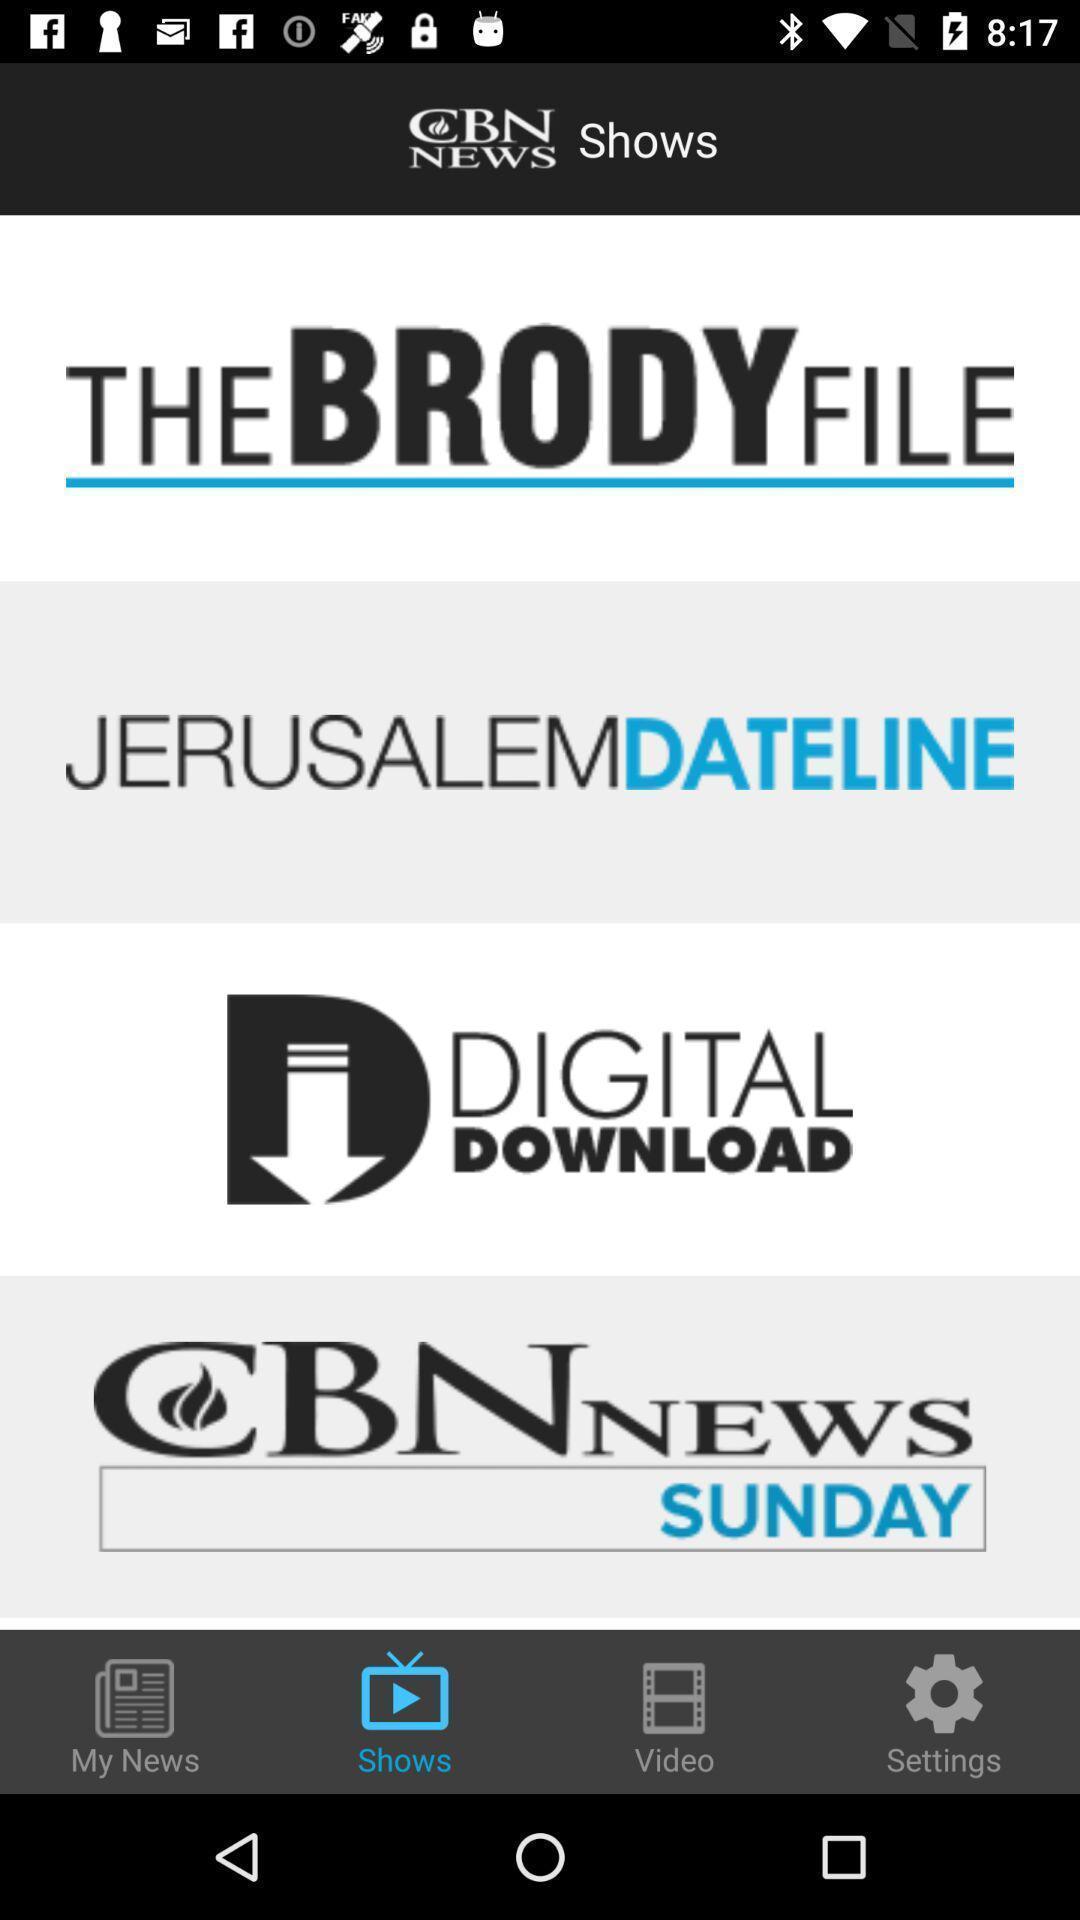What details can you identify in this image? Page displaying the list of shows. 